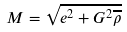<formula> <loc_0><loc_0><loc_500><loc_500>M = \sqrt { e ^ { 2 } + G ^ { 2 } \overline { \rho } }</formula> 